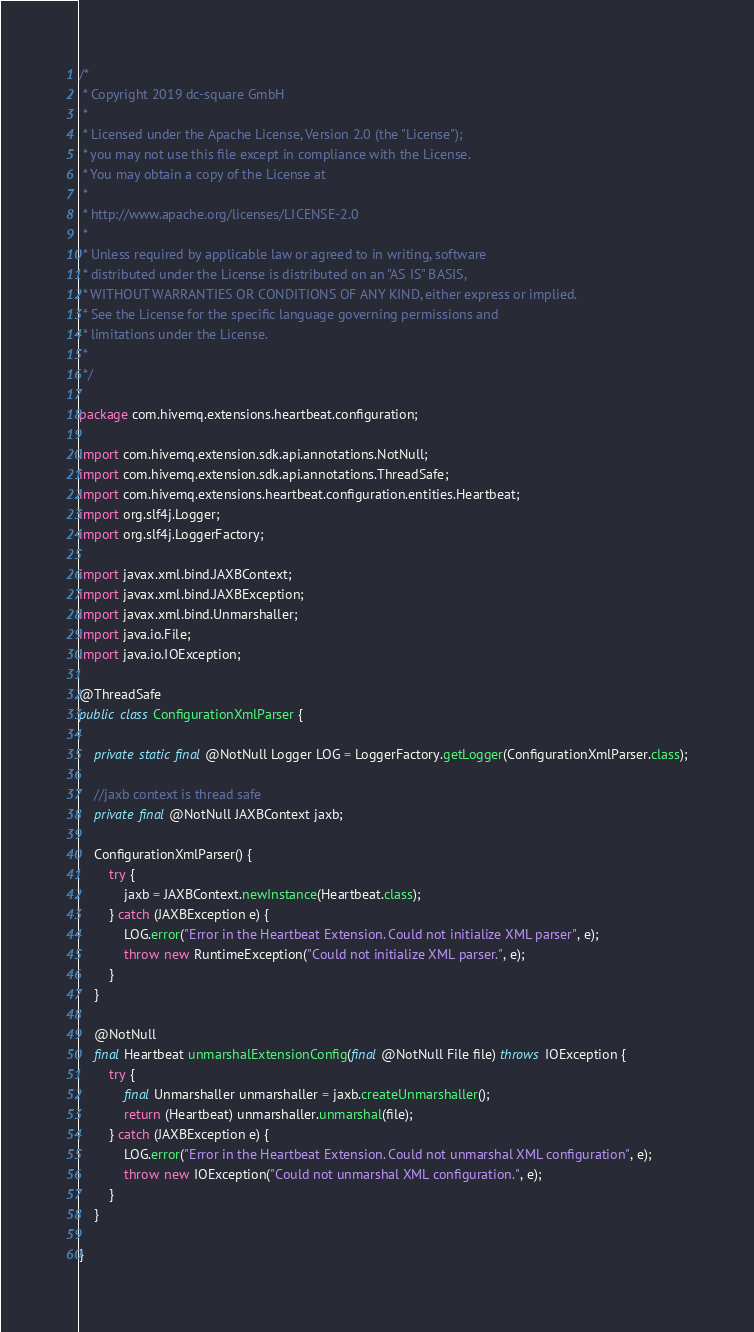<code> <loc_0><loc_0><loc_500><loc_500><_Java_>/*
 * Copyright 2019 dc-square GmbH
 *
 * Licensed under the Apache License, Version 2.0 (the "License");
 * you may not use this file except in compliance with the License.
 * You may obtain a copy of the License at
 *
 * http://www.apache.org/licenses/LICENSE-2.0
 *
 * Unless required by applicable law or agreed to in writing, software
 * distributed under the License is distributed on an "AS IS" BASIS,
 * WITHOUT WARRANTIES OR CONDITIONS OF ANY KIND, either express or implied.
 * See the License for the specific language governing permissions and
 * limitations under the License.
 *
 */

package com.hivemq.extensions.heartbeat.configuration;

import com.hivemq.extension.sdk.api.annotations.NotNull;
import com.hivemq.extension.sdk.api.annotations.ThreadSafe;
import com.hivemq.extensions.heartbeat.configuration.entities.Heartbeat;
import org.slf4j.Logger;
import org.slf4j.LoggerFactory;

import javax.xml.bind.JAXBContext;
import javax.xml.bind.JAXBException;
import javax.xml.bind.Unmarshaller;
import java.io.File;
import java.io.IOException;

@ThreadSafe
public class ConfigurationXmlParser {

    private static final @NotNull Logger LOG = LoggerFactory.getLogger(ConfigurationXmlParser.class);

    //jaxb context is thread safe
    private final @NotNull JAXBContext jaxb;

    ConfigurationXmlParser() {
        try {
            jaxb = JAXBContext.newInstance(Heartbeat.class);
        } catch (JAXBException e) {
            LOG.error("Error in the Heartbeat Extension. Could not initialize XML parser", e);
            throw new RuntimeException("Could not initialize XML parser.", e);
        }
    }

    @NotNull
    final Heartbeat unmarshalExtensionConfig(final @NotNull File file) throws IOException {
        try {
            final Unmarshaller unmarshaller = jaxb.createUnmarshaller();
            return (Heartbeat) unmarshaller.unmarshal(file);
        } catch (JAXBException e) {
            LOG.error("Error in the Heartbeat Extension. Could not unmarshal XML configuration", e);
            throw new IOException("Could not unmarshal XML configuration.", e);
        }
    }

}
</code> 